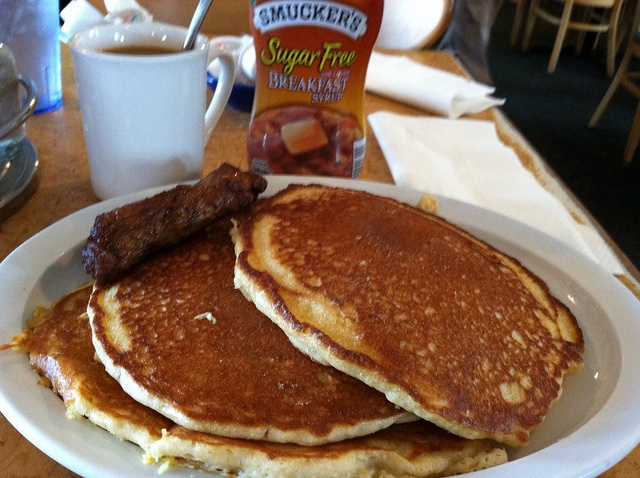Describe the objects in this image and their specific colors. I can see dining table in maroon, gray, brown, darkgray, and lightgray tones, cup in gray, lightblue, and darkgray tones, bottle in gray, maroon, brown, and olive tones, cup in gray and lightblue tones, and chair in gray and black tones in this image. 